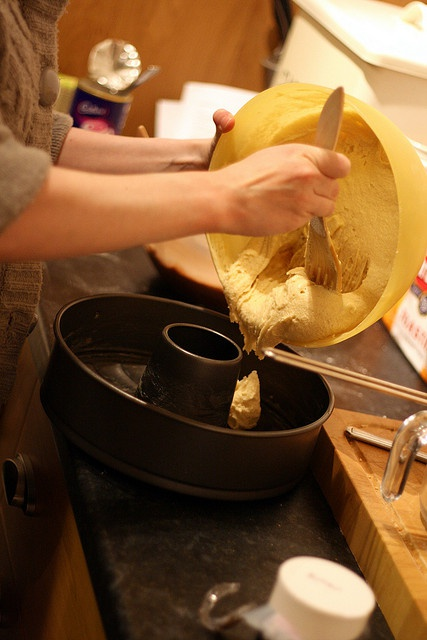Describe the objects in this image and their specific colors. I can see people in maroon, brown, tan, and gray tones, bowl in olive, orange, red, and gold tones, cup in olive, beige, and tan tones, fork in olive, brown, maroon, and orange tones, and clock in olive, tan, beige, and brown tones in this image. 